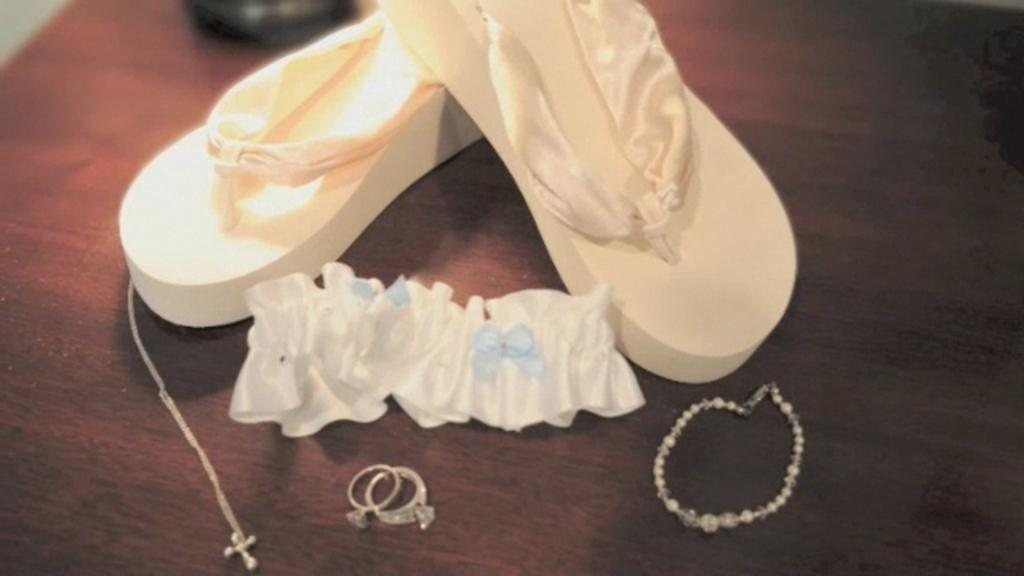What type of footwear is visible in the image? There is white color footwear in the image. What type of jewelry can be seen in the image? There are rings, a chain, and a bracelet in the image. What material is present in the image? There is a cloth in the image. What is the color of the surface in the image? The surface in the image is brown color. Can you hear the sound of thunder in the image? There is no sound or indication of thunder in the image; it is a still image. What type of record is being played in the image? There is no record or any indication of music playing in the image. 